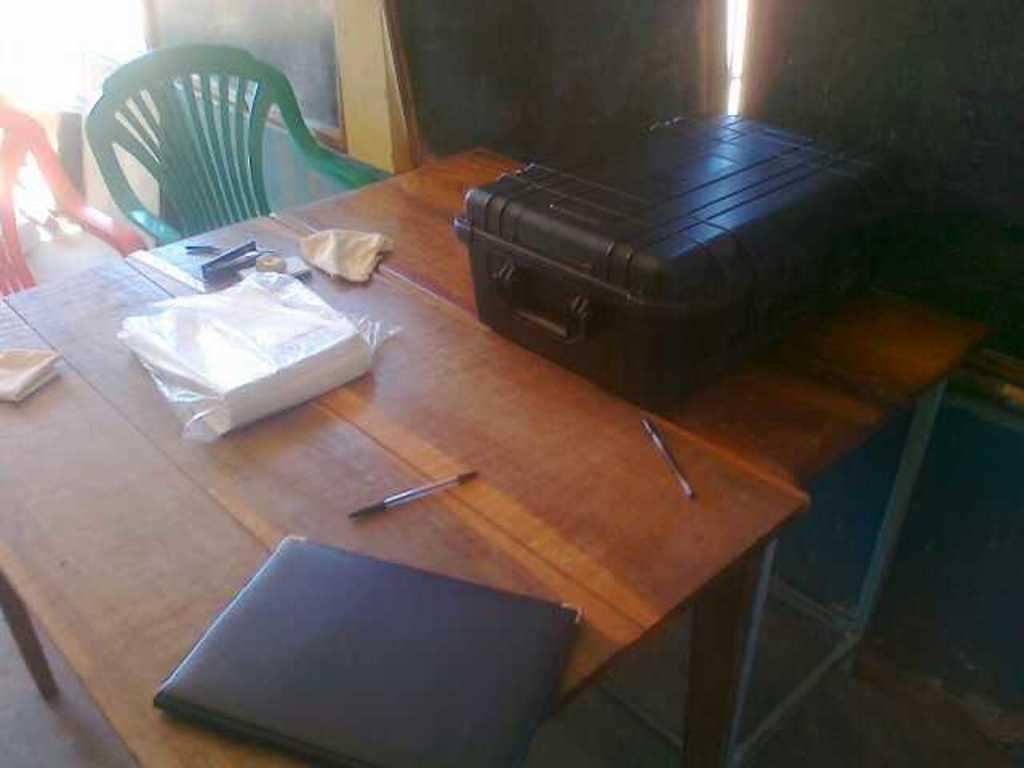In one or two sentences, can you explain what this image depicts? In the image we can see there is a table on which there is a suitcase, booklet, open, file and there is a chair. 